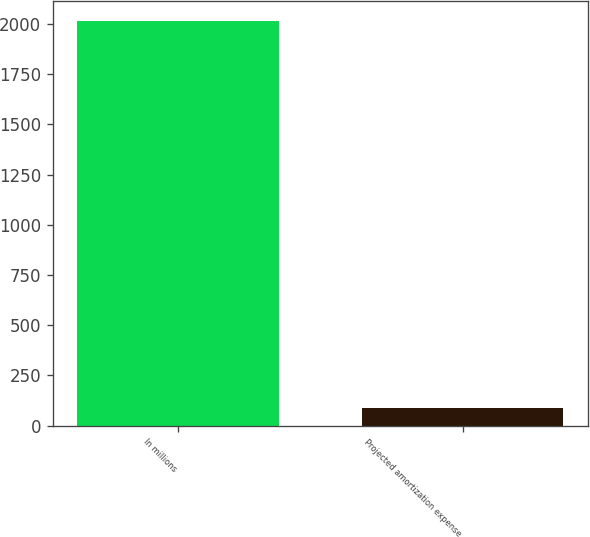<chart> <loc_0><loc_0><loc_500><loc_500><bar_chart><fcel>In millions<fcel>Projected amortization expense<nl><fcel>2015<fcel>86<nl></chart> 